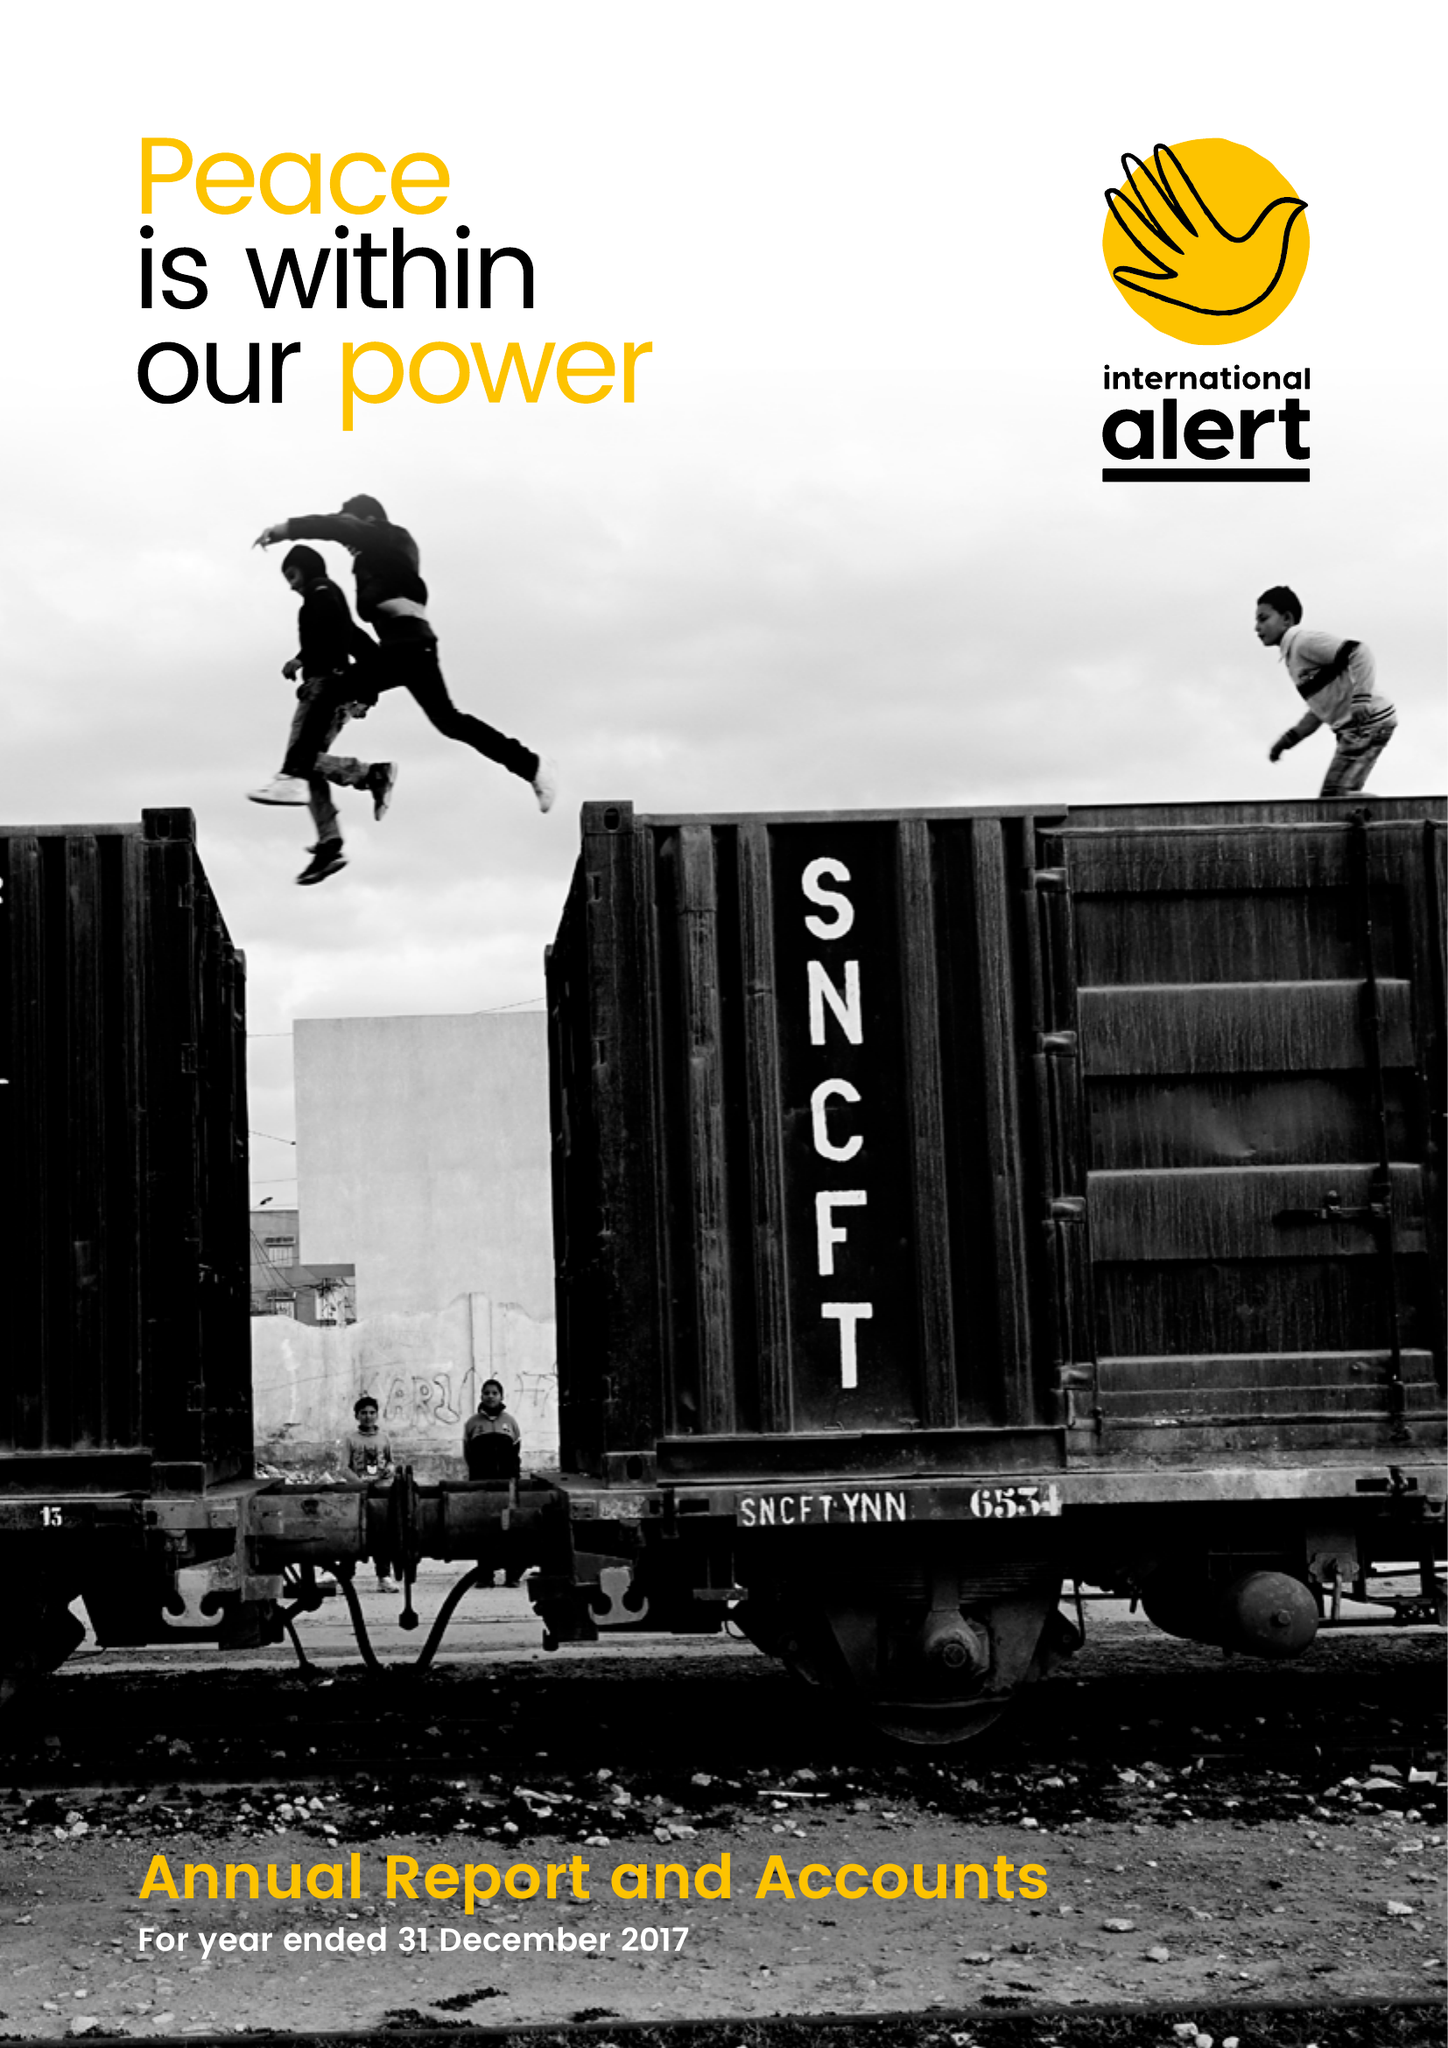What is the value for the charity_name?
Answer the question using a single word or phrase. International Alert 